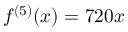<formula> <loc_0><loc_0><loc_500><loc_500>f ^ { ( 5 ) } ( x ) = 7 2 0 x</formula> 